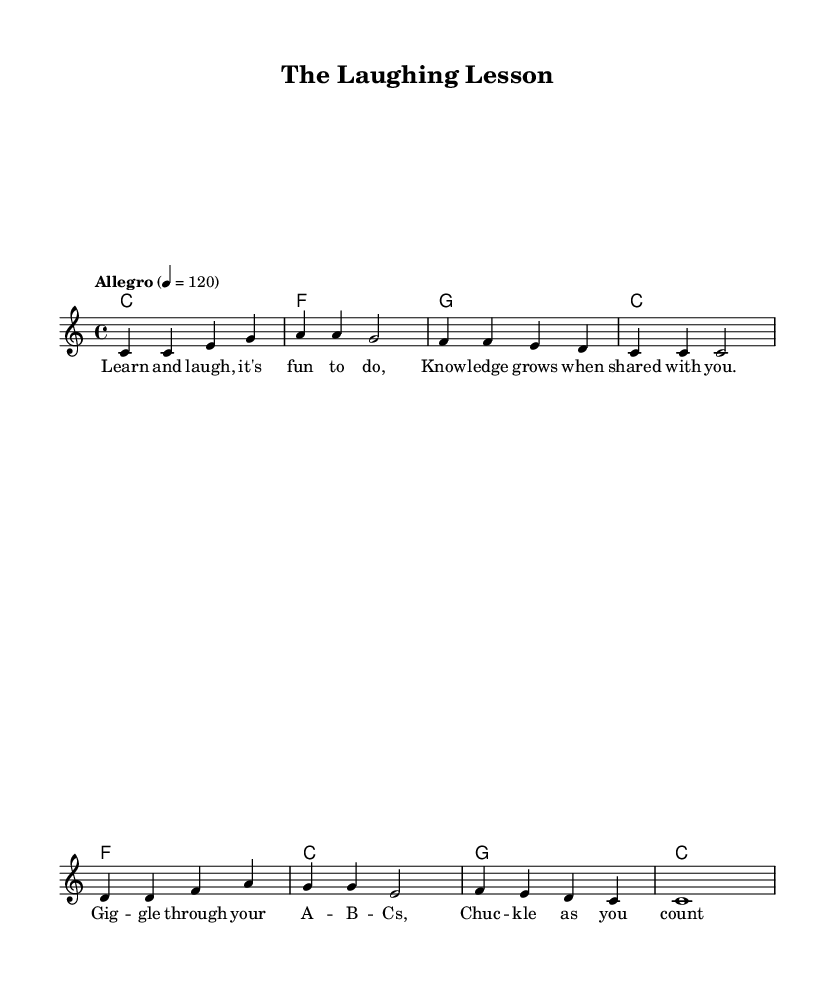What is the key signature of this music? The key signature is C major, which has no sharps or flats.
Answer: C major What is the time signature of this piece? The time signature is found at the beginning of the sheet music, showing that there are four beats per measure.
Answer: 4/4 What is the tempo marking? The tempo marking indicates that the piece should be played at a lively speed of 120 beats per minute.
Answer: Allegro 4 = 120 What is the rhythmic value of the last note in the melody? The last note in the melody is a whole note, indicated by the notation spanning across the full measure with no additional divisions.
Answer: c1 How many measures are in the melody section? By counting the measures in the melody part, there are a total of 8 measures in the melody.
Answer: 8 Which musical section is labeled as “verse” in the lyrics? The section labeled "verse" contains the lyrics that accompany the melody and inform the educational theme, emphasizing learning and laughter.
Answer: Learn and laugh, it's fun to do.. What is the nature of the song's lyrics? The lyrics use playful language to convey educational themes, encouraging laughter and learning in a fun way for children.
Answer: Humorous 